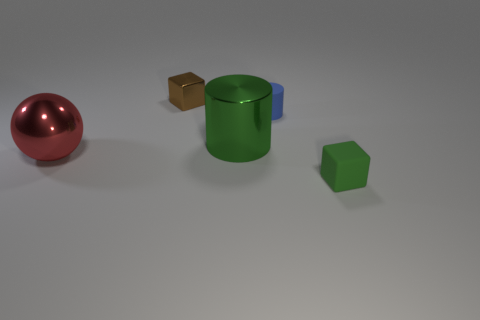Add 2 small blue matte objects. How many objects exist? 7 Subtract all cylinders. How many objects are left? 3 Add 2 tiny yellow metallic balls. How many tiny yellow metallic balls exist? 2 Subtract 1 brown cubes. How many objects are left? 4 Subtract all small blue metal blocks. Subtract all brown metallic cubes. How many objects are left? 4 Add 2 large green shiny cylinders. How many large green shiny cylinders are left? 3 